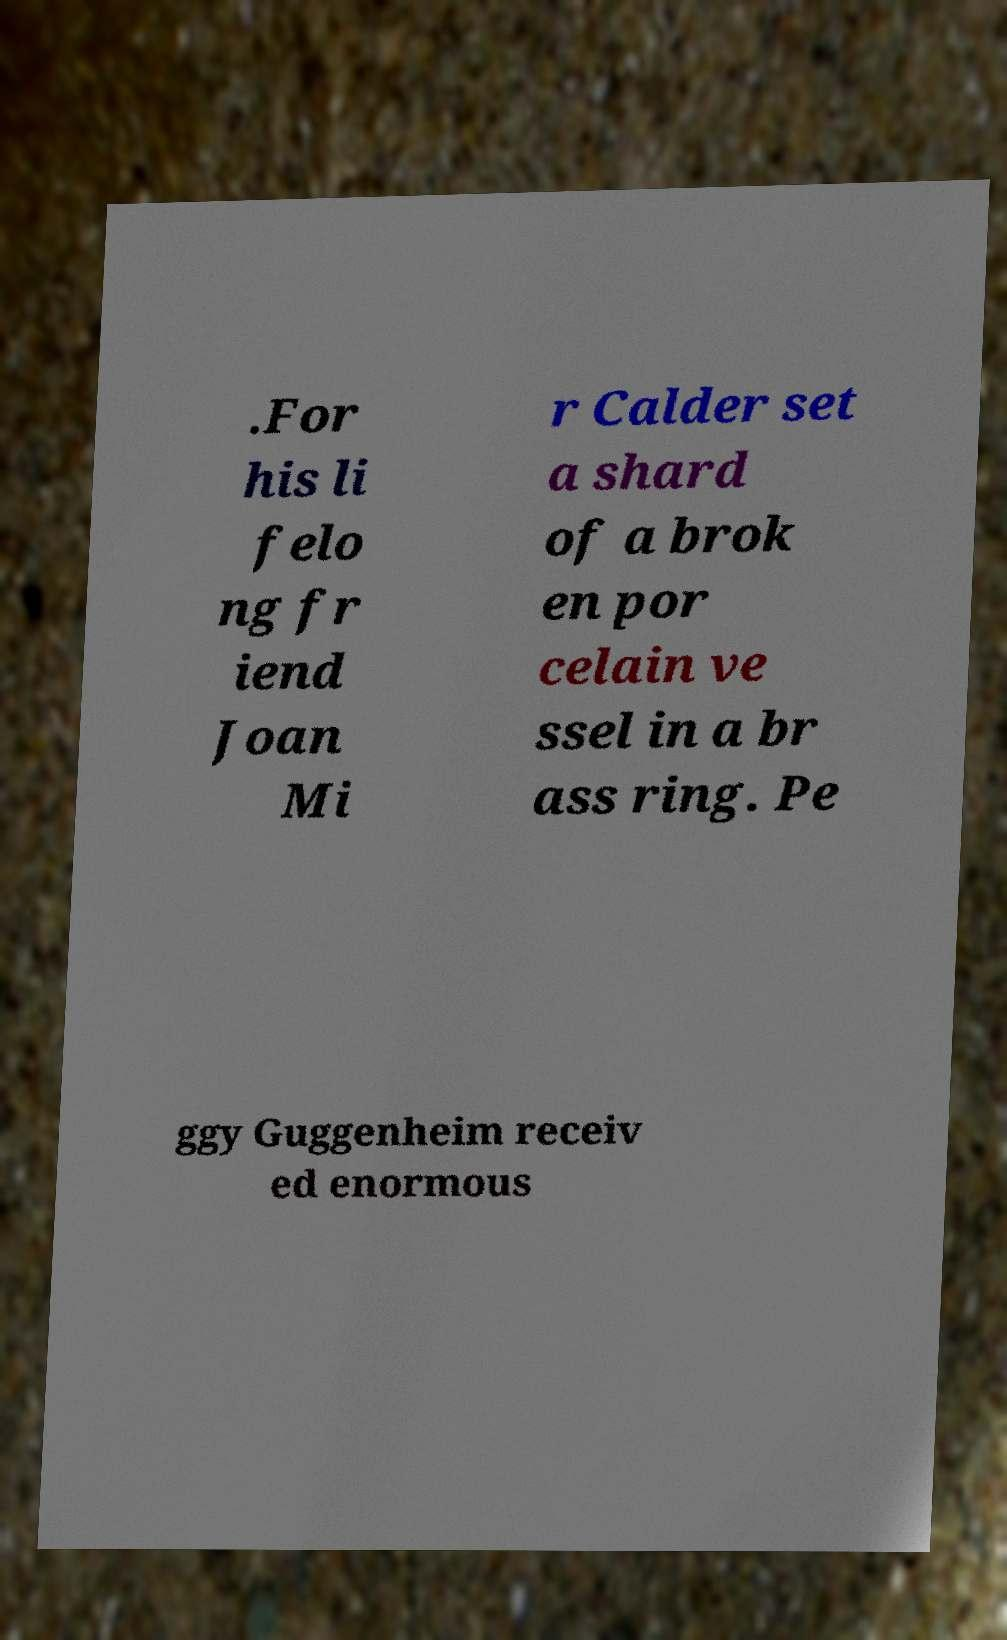Can you read and provide the text displayed in the image?This photo seems to have some interesting text. Can you extract and type it out for me? .For his li felo ng fr iend Joan Mi r Calder set a shard of a brok en por celain ve ssel in a br ass ring. Pe ggy Guggenheim receiv ed enormous 